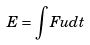Convert formula to latex. <formula><loc_0><loc_0><loc_500><loc_500>E = \int F u d t</formula> 